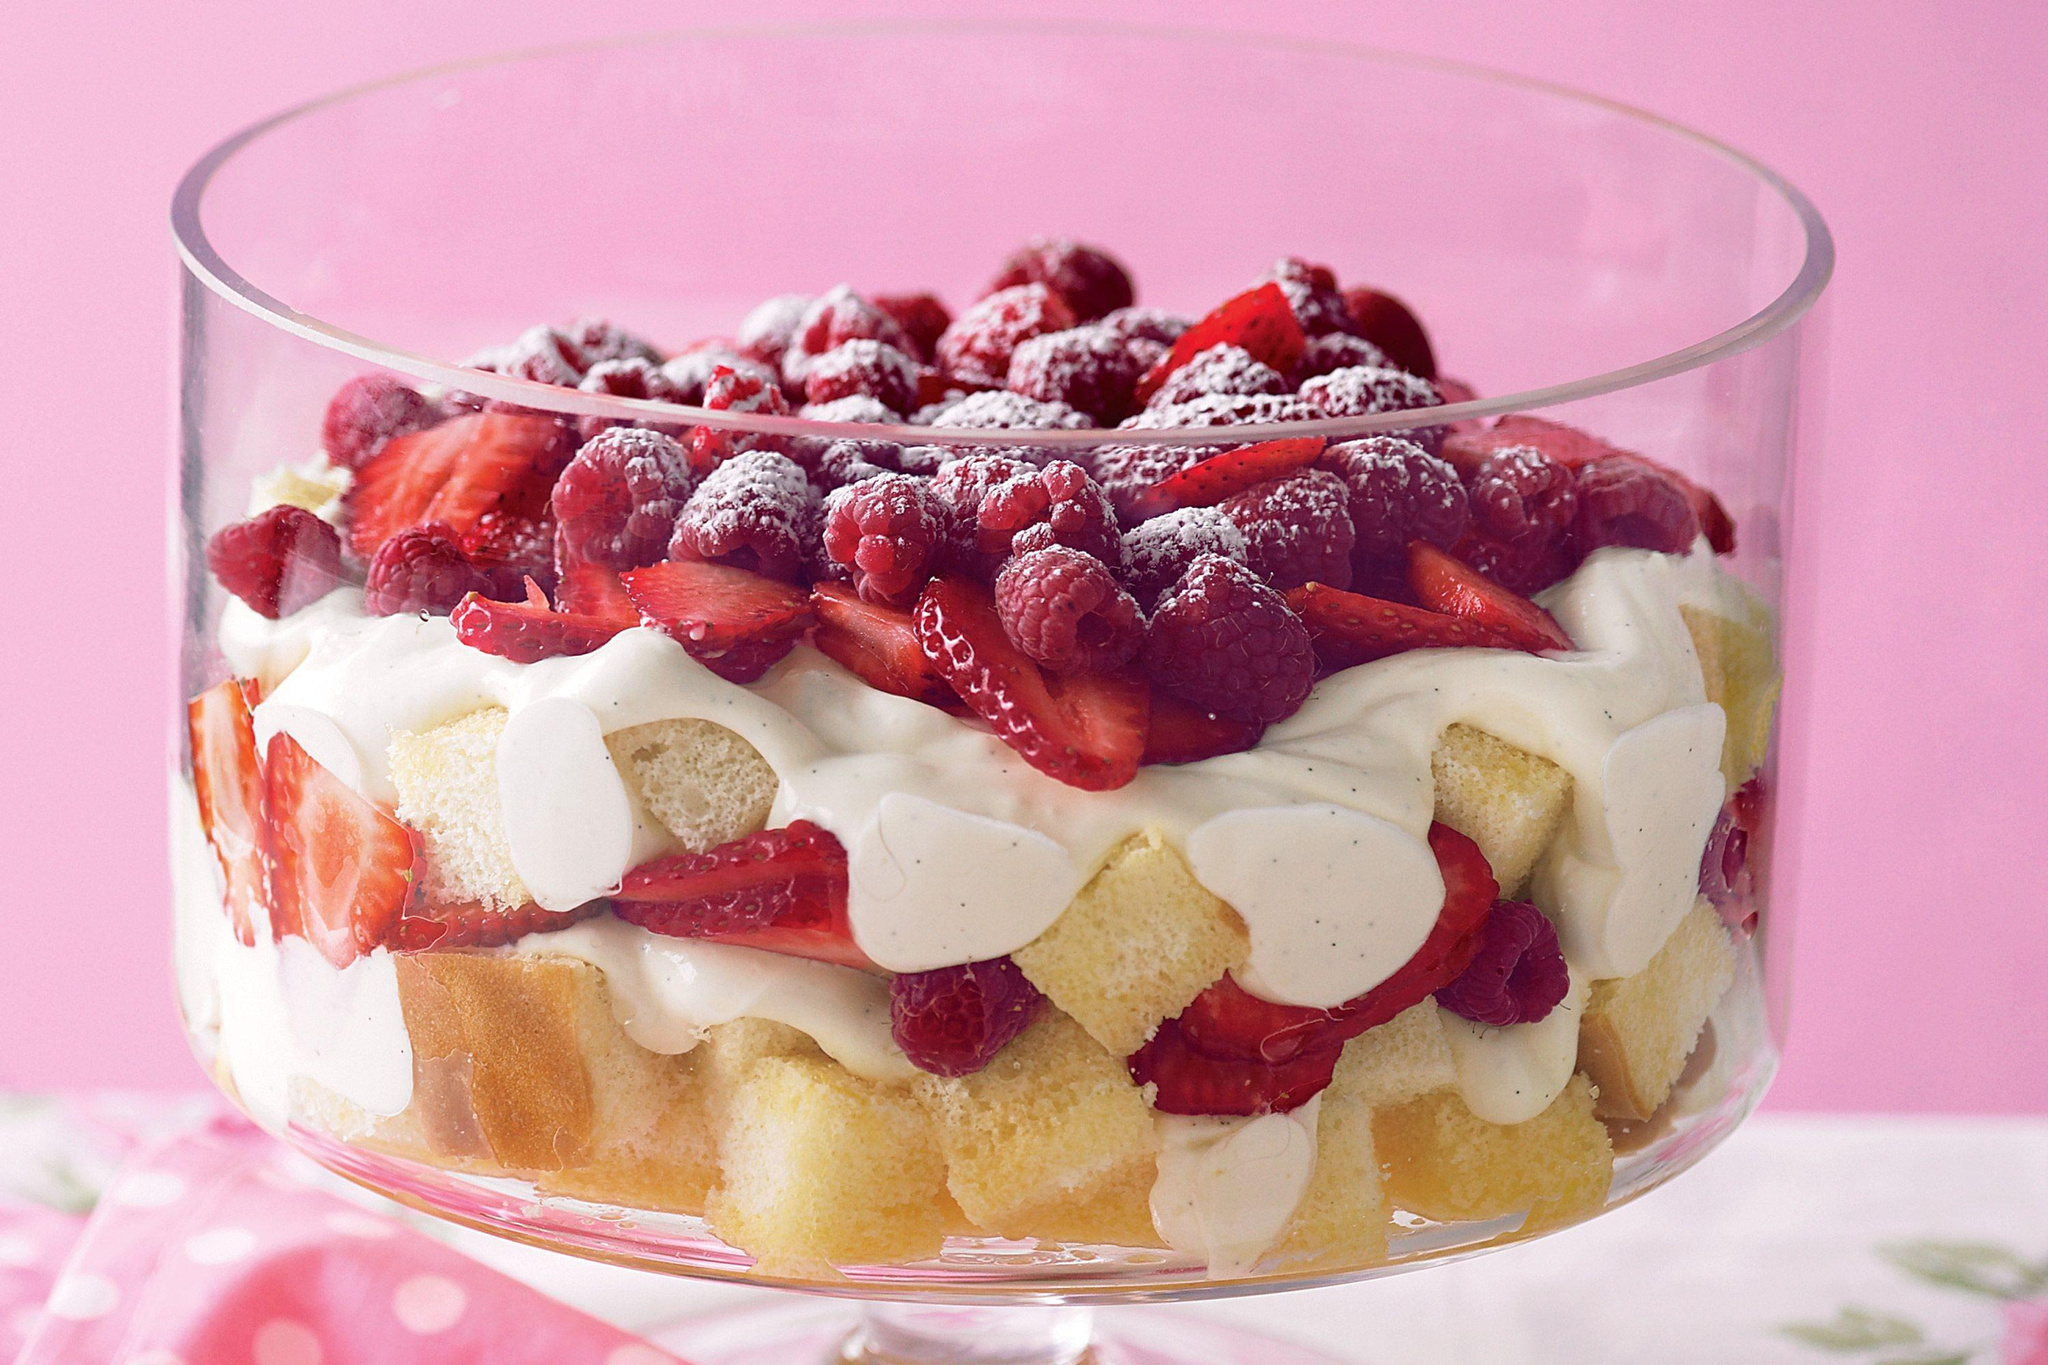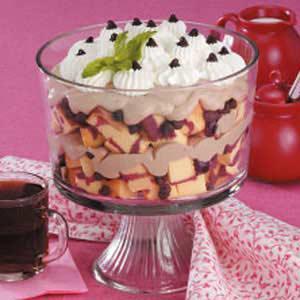The first image is the image on the left, the second image is the image on the right. For the images displayed, is the sentence "An image shows a whip cream-topped dessert garnished with one red colored berries and a green leafy sprig." factually correct? Answer yes or no. No. The first image is the image on the left, the second image is the image on the right. Examine the images to the left and right. Is the description "The desserts in one of the images are dished out into single servings." accurate? Answer yes or no. No. 